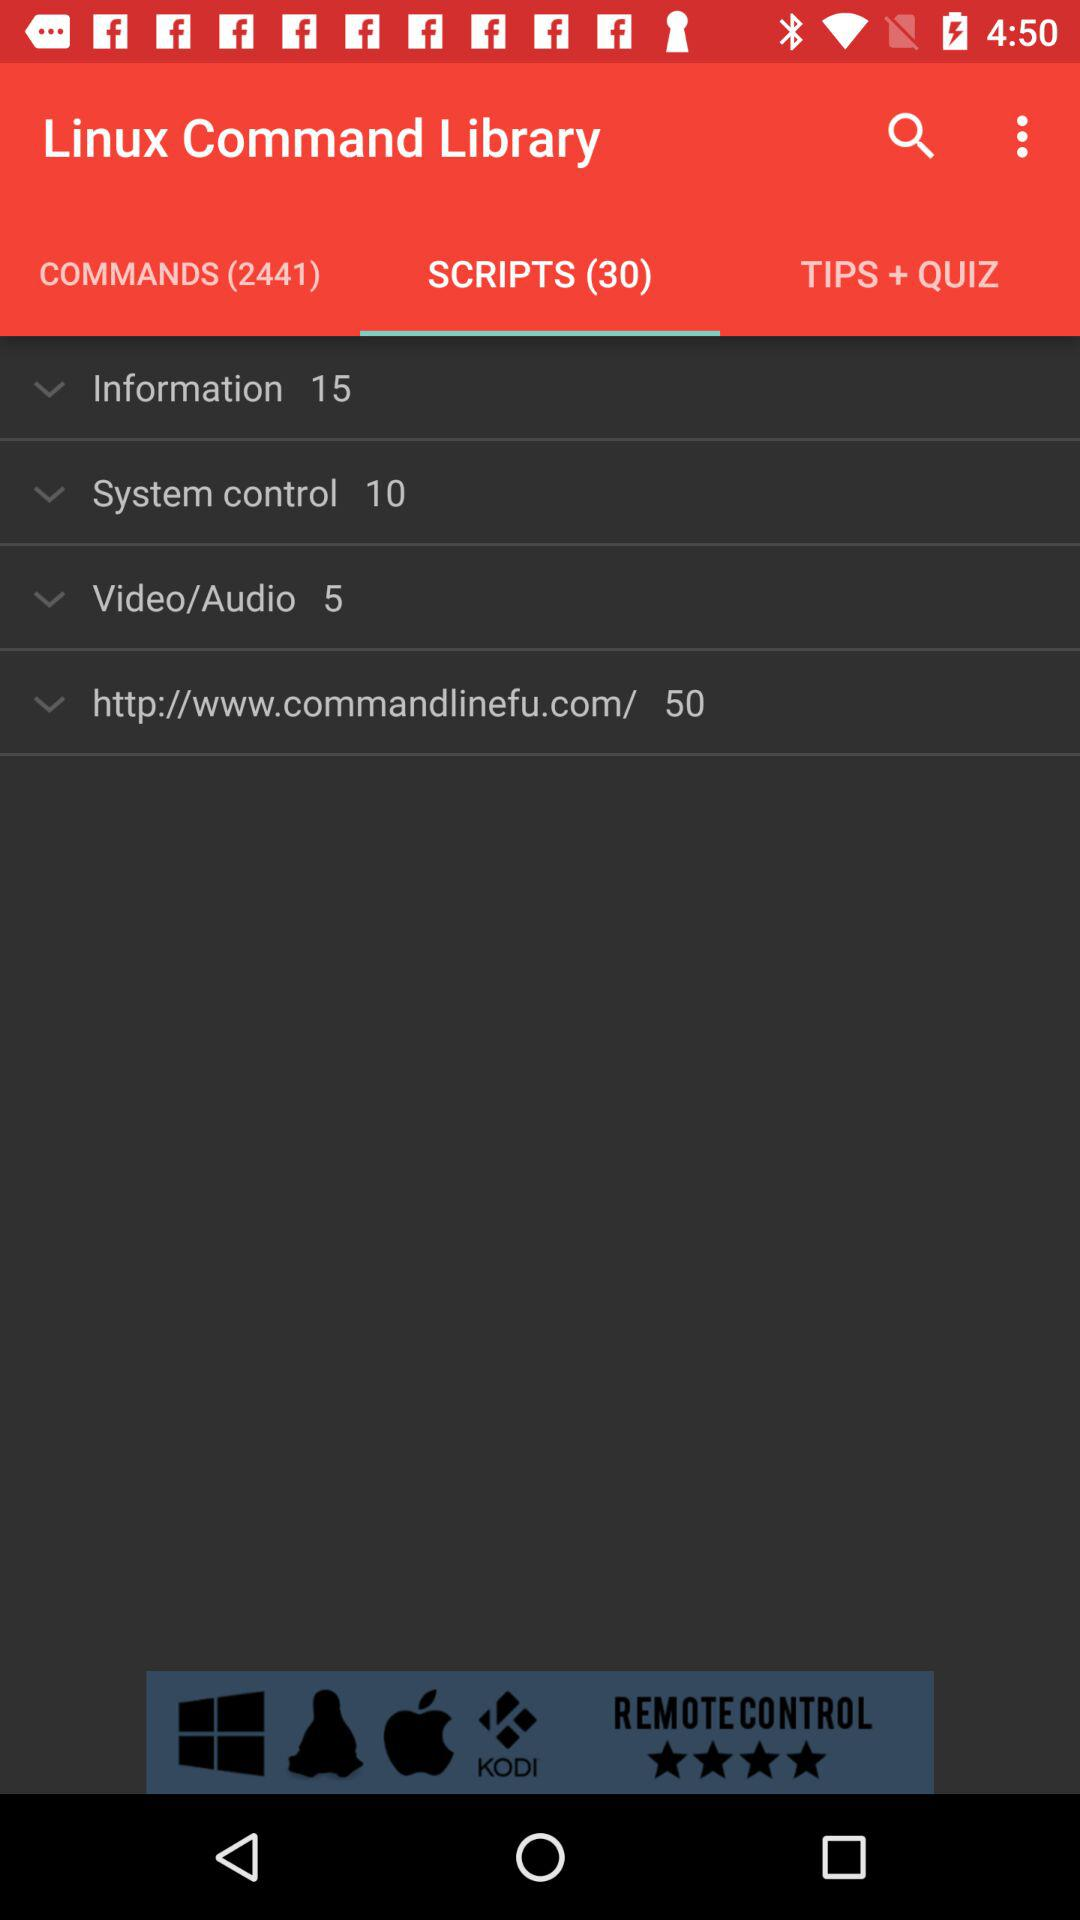What is the number of scripts in "Video/Audio"? The number of scripts in "Video/Audio" is 5. 